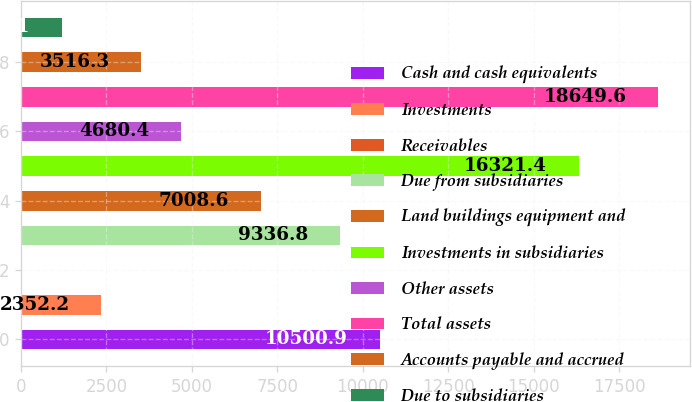Convert chart. <chart><loc_0><loc_0><loc_500><loc_500><bar_chart><fcel>Cash and cash equivalents<fcel>Investments<fcel>Receivables<fcel>Due from subsidiaries<fcel>Land buildings equipment and<fcel>Investments in subsidiaries<fcel>Other assets<fcel>Total assets<fcel>Accounts payable and accrued<fcel>Due to subsidiaries<nl><fcel>10500.9<fcel>2352.2<fcel>24<fcel>9336.8<fcel>7008.6<fcel>16321.4<fcel>4680.4<fcel>18649.6<fcel>3516.3<fcel>1188.1<nl></chart> 